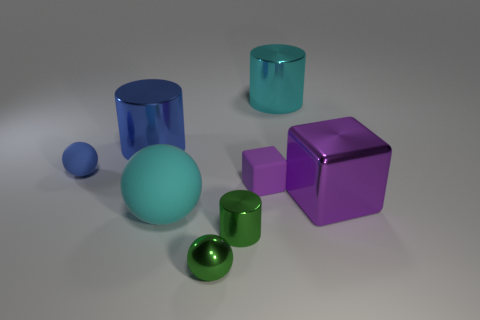There is a block behind the big purple thing; how many blue rubber spheres are in front of it?
Ensure brevity in your answer.  0. Is the number of small rubber blocks that are on the left side of the big ball less than the number of tiny rubber things?
Provide a short and direct response. Yes. What shape is the big metallic thing that is on the right side of the cylinder right of the metallic cylinder in front of the purple rubber block?
Keep it short and to the point. Cube. Does the large cyan metal thing have the same shape as the purple metallic object?
Offer a terse response. No. What number of other things are there of the same shape as the big blue object?
Offer a terse response. 2. What is the color of the other sphere that is the same size as the green metallic ball?
Give a very brief answer. Blue. Are there the same number of purple shiny cubes that are on the left side of the matte block and cylinders?
Your answer should be very brief. No. There is a big thing that is in front of the purple matte cube and left of the tiny matte cube; what is its shape?
Offer a terse response. Sphere. Does the blue cylinder have the same size as the cyan metal cylinder?
Keep it short and to the point. Yes. Is there a big gray block made of the same material as the green cylinder?
Give a very brief answer. No. 